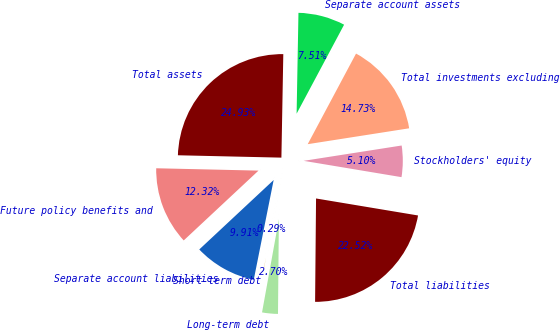<chart> <loc_0><loc_0><loc_500><loc_500><pie_chart><fcel>Total investments excluding<fcel>Separate account assets<fcel>Total assets<fcel>Future policy benefits and<fcel>Separate account liabilities<fcel>Short-term debt<fcel>Long-term debt<fcel>Total liabilities<fcel>Stockholders' equity<nl><fcel>14.73%<fcel>7.51%<fcel>24.93%<fcel>12.32%<fcel>9.91%<fcel>0.29%<fcel>2.7%<fcel>22.52%<fcel>5.1%<nl></chart> 